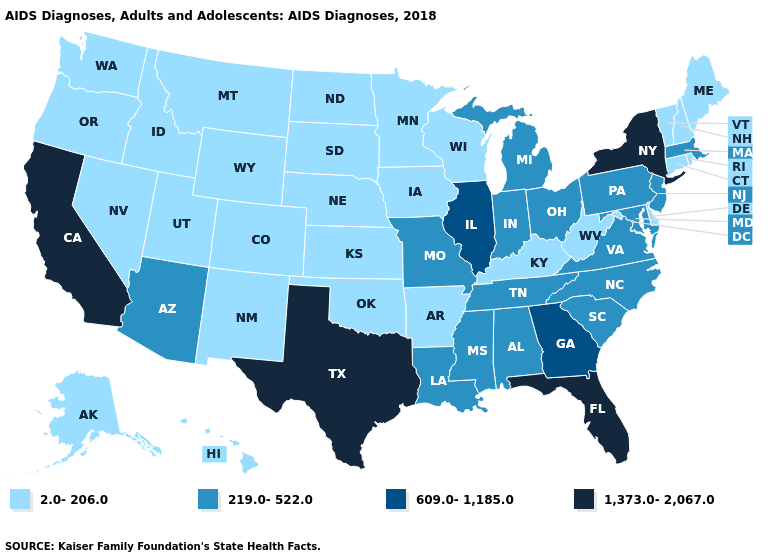Does Washington have the same value as Missouri?
Give a very brief answer. No. Does Vermont have the highest value in the Northeast?
Quick response, please. No. What is the value of Tennessee?
Concise answer only. 219.0-522.0. What is the value of Missouri?
Give a very brief answer. 219.0-522.0. Name the states that have a value in the range 1,373.0-2,067.0?
Give a very brief answer. California, Florida, New York, Texas. Does the map have missing data?
Keep it brief. No. How many symbols are there in the legend?
Write a very short answer. 4. Among the states that border Delaware , which have the highest value?
Answer briefly. Maryland, New Jersey, Pennsylvania. Name the states that have a value in the range 2.0-206.0?
Quick response, please. Alaska, Arkansas, Colorado, Connecticut, Delaware, Hawaii, Idaho, Iowa, Kansas, Kentucky, Maine, Minnesota, Montana, Nebraska, Nevada, New Hampshire, New Mexico, North Dakota, Oklahoma, Oregon, Rhode Island, South Dakota, Utah, Vermont, Washington, West Virginia, Wisconsin, Wyoming. What is the highest value in the South ?
Answer briefly. 1,373.0-2,067.0. What is the lowest value in the South?
Be succinct. 2.0-206.0. What is the value of Kansas?
Write a very short answer. 2.0-206.0. Among the states that border Colorado , which have the highest value?
Keep it brief. Arizona. Name the states that have a value in the range 2.0-206.0?
Give a very brief answer. Alaska, Arkansas, Colorado, Connecticut, Delaware, Hawaii, Idaho, Iowa, Kansas, Kentucky, Maine, Minnesota, Montana, Nebraska, Nevada, New Hampshire, New Mexico, North Dakota, Oklahoma, Oregon, Rhode Island, South Dakota, Utah, Vermont, Washington, West Virginia, Wisconsin, Wyoming. What is the value of Colorado?
Short answer required. 2.0-206.0. 